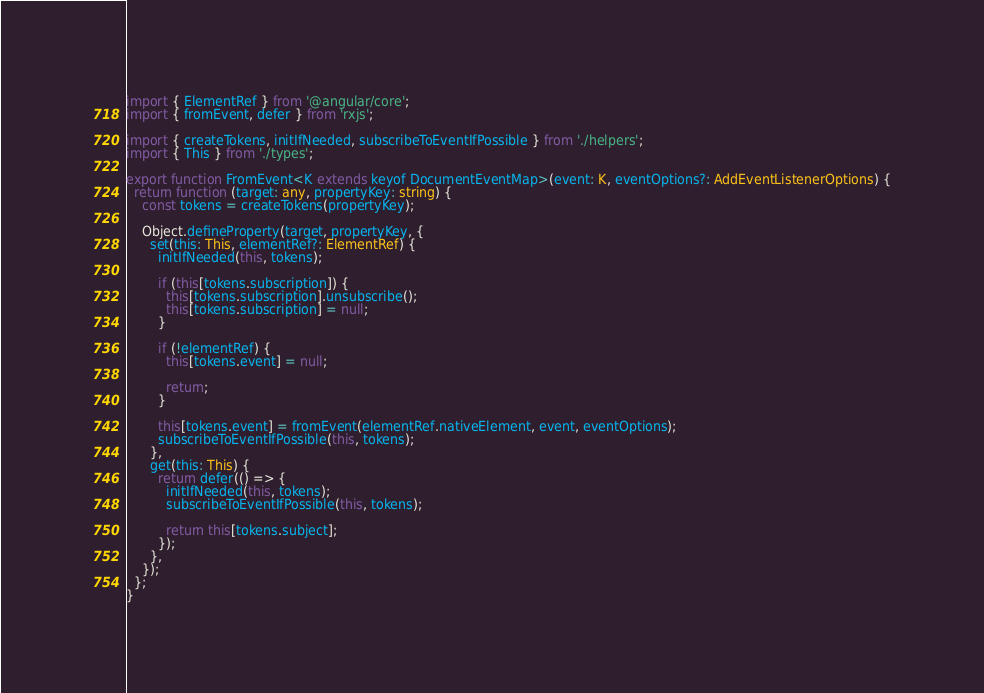Convert code to text. <code><loc_0><loc_0><loc_500><loc_500><_TypeScript_>import { ElementRef } from '@angular/core';
import { fromEvent, defer } from 'rxjs';

import { createTokens, initIfNeeded, subscribeToEventIfPossible } from './helpers';
import { This } from './types';

export function FromEvent<K extends keyof DocumentEventMap>(event: K, eventOptions?: AddEventListenerOptions) {
  return function (target: any, propertyKey: string) {
    const tokens = createTokens(propertyKey);

    Object.defineProperty(target, propertyKey, {
      set(this: This, elementRef?: ElementRef) {
        initIfNeeded(this, tokens);

        if (this[tokens.subscription]) {
          this[tokens.subscription].unsubscribe();
          this[tokens.subscription] = null;
        }

        if (!elementRef) {
          this[tokens.event] = null;

          return;
        }

        this[tokens.event] = fromEvent(elementRef.nativeElement, event, eventOptions);
        subscribeToEventIfPossible(this, tokens);
      },
      get(this: This) {
        return defer(() => {
          initIfNeeded(this, tokens);
          subscribeToEventIfPossible(this, tokens);

          return this[tokens.subject];
        });
      },
    });
  };
}
</code> 